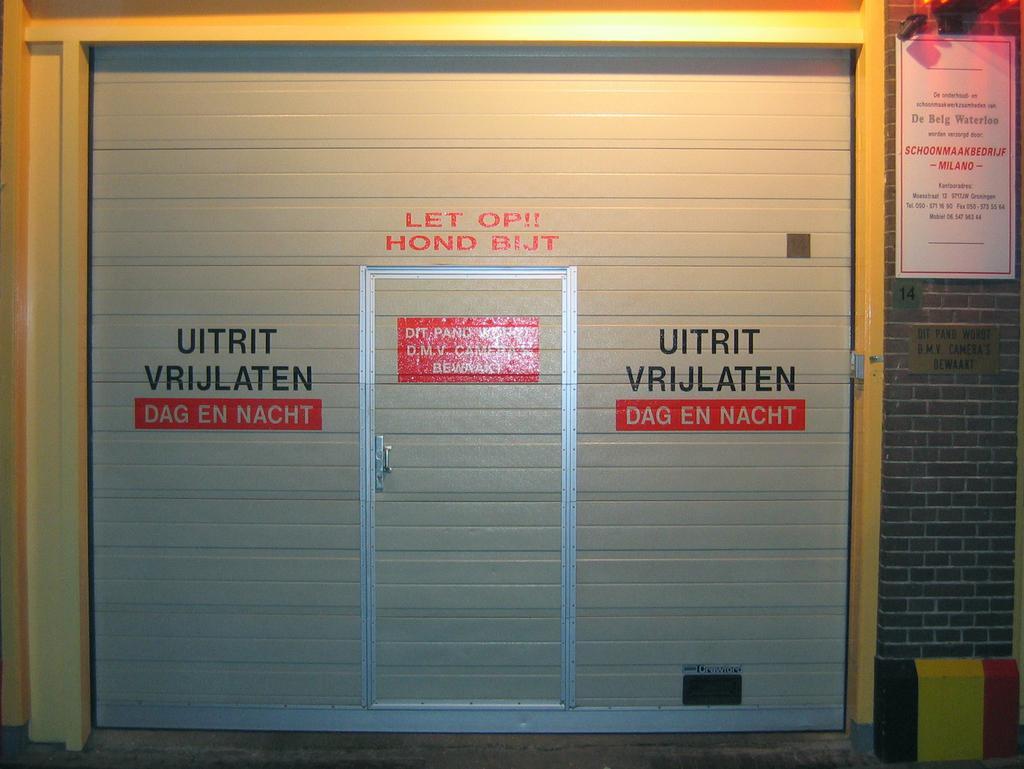How would you summarize this image in a sentence or two? The picture consists of a shutter. In the center of the shutter there is a door. On the shutter there is text. On the right there is a brick wall, on the wall there are poster and name plate. 